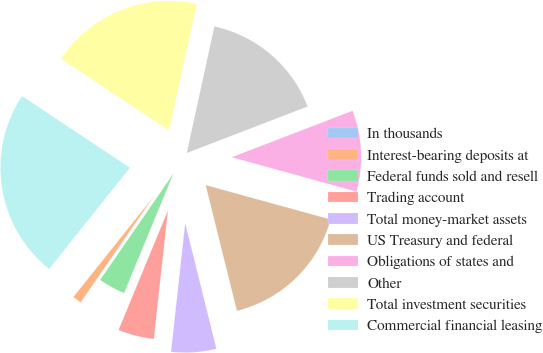<chart> <loc_0><loc_0><loc_500><loc_500><pie_chart><fcel>In thousands<fcel>Interest-bearing deposits at<fcel>Federal funds sold and resell<fcel>Trading account<fcel>Total money-market assets<fcel>US Treasury and federal<fcel>Obligations of states and<fcel>Other<fcel>Total investment securities<fcel>Commercial financial leasing<nl><fcel>0.0%<fcel>1.12%<fcel>3.37%<fcel>4.49%<fcel>5.62%<fcel>16.85%<fcel>10.11%<fcel>15.73%<fcel>19.1%<fcel>23.59%<nl></chart> 